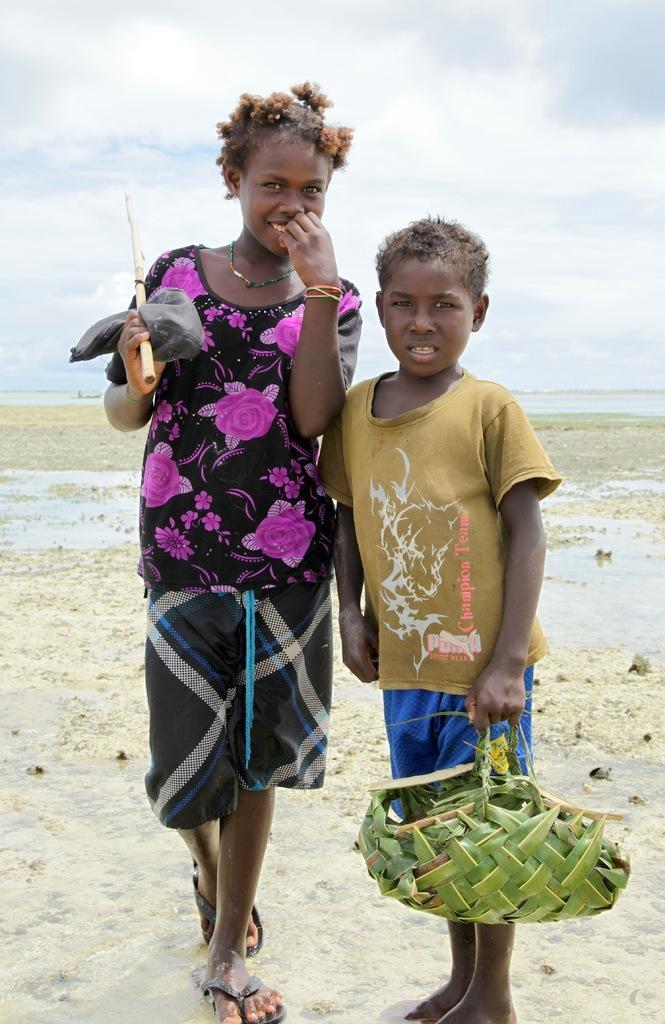Describe this image in one or two sentences. In this picture there is a woman standing and smiling and there is a boy standing and holding the basket. At the back there is water. At the top there is sky and there are clouds. At the bottom there is sand and water. 